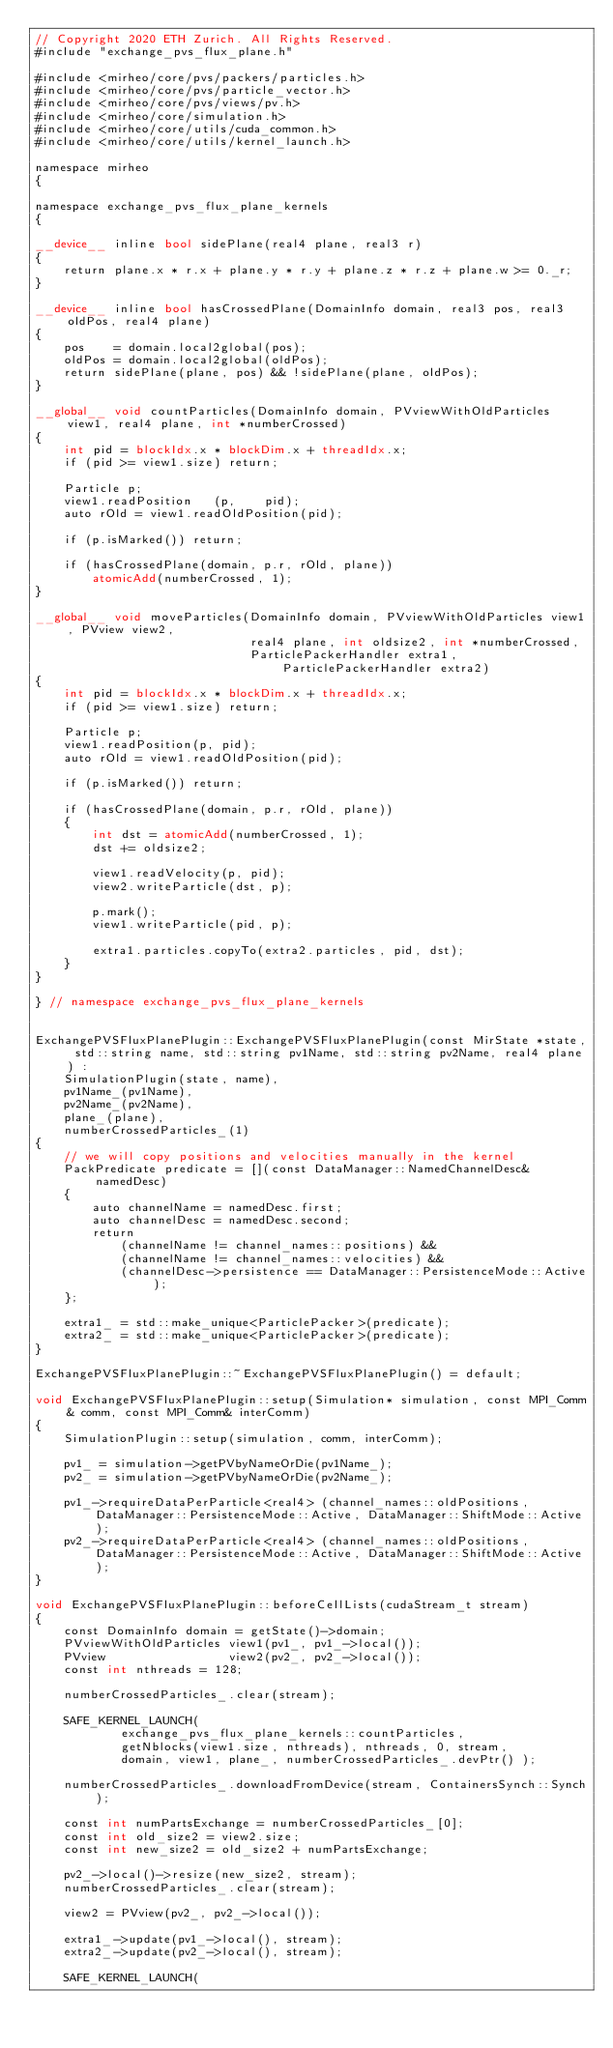Convert code to text. <code><loc_0><loc_0><loc_500><loc_500><_Cuda_>// Copyright 2020 ETH Zurich. All Rights Reserved.
#include "exchange_pvs_flux_plane.h"

#include <mirheo/core/pvs/packers/particles.h>
#include <mirheo/core/pvs/particle_vector.h>
#include <mirheo/core/pvs/views/pv.h>
#include <mirheo/core/simulation.h>
#include <mirheo/core/utils/cuda_common.h>
#include <mirheo/core/utils/kernel_launch.h>

namespace mirheo
{

namespace exchange_pvs_flux_plane_kernels
{

__device__ inline bool sidePlane(real4 plane, real3 r)
{
    return plane.x * r.x + plane.y * r.y + plane.z * r.z + plane.w >= 0._r;
}

__device__ inline bool hasCrossedPlane(DomainInfo domain, real3 pos, real3 oldPos, real4 plane)
{
    pos    = domain.local2global(pos);
    oldPos = domain.local2global(oldPos);
    return sidePlane(plane, pos) && !sidePlane(plane, oldPos);
}

__global__ void countParticles(DomainInfo domain, PVviewWithOldParticles view1, real4 plane, int *numberCrossed)
{
    int pid = blockIdx.x * blockDim.x + threadIdx.x;
    if (pid >= view1.size) return;

    Particle p;
    view1.readPosition   (p,    pid);
    auto rOld = view1.readOldPosition(pid);

    if (p.isMarked()) return;

    if (hasCrossedPlane(domain, p.r, rOld, plane))
        atomicAdd(numberCrossed, 1);
}

__global__ void moveParticles(DomainInfo domain, PVviewWithOldParticles view1, PVview view2,
                              real4 plane, int oldsize2, int *numberCrossed,
                              ParticlePackerHandler extra1, ParticlePackerHandler extra2)
{
    int pid = blockIdx.x * blockDim.x + threadIdx.x;
    if (pid >= view1.size) return;

    Particle p;
    view1.readPosition(p, pid);
    auto rOld = view1.readOldPosition(pid);

    if (p.isMarked()) return;

    if (hasCrossedPlane(domain, p.r, rOld, plane))
    {
        int dst = atomicAdd(numberCrossed, 1);
        dst += oldsize2;

        view1.readVelocity(p, pid);
        view2.writeParticle(dst, p);

        p.mark();
        view1.writeParticle(pid, p);

        extra1.particles.copyTo(extra2.particles, pid, dst);
    }
}

} // namespace exchange_pvs_flux_plane_kernels


ExchangePVSFluxPlanePlugin::ExchangePVSFluxPlanePlugin(const MirState *state, std::string name, std::string pv1Name, std::string pv2Name, real4 plane) :
    SimulationPlugin(state, name),
    pv1Name_(pv1Name),
    pv2Name_(pv2Name),
    plane_(plane),
    numberCrossedParticles_(1)
{
    // we will copy positions and velocities manually in the kernel
    PackPredicate predicate = [](const DataManager::NamedChannelDesc& namedDesc)
    {
        auto channelName = namedDesc.first;
        auto channelDesc = namedDesc.second;
        return
            (channelName != channel_names::positions) &&
            (channelName != channel_names::velocities) &&
            (channelDesc->persistence == DataManager::PersistenceMode::Active);
    };

    extra1_ = std::make_unique<ParticlePacker>(predicate);
    extra2_ = std::make_unique<ParticlePacker>(predicate);
}

ExchangePVSFluxPlanePlugin::~ExchangePVSFluxPlanePlugin() = default;

void ExchangePVSFluxPlanePlugin::setup(Simulation* simulation, const MPI_Comm& comm, const MPI_Comm& interComm)
{
    SimulationPlugin::setup(simulation, comm, interComm);

    pv1_ = simulation->getPVbyNameOrDie(pv1Name_);
    pv2_ = simulation->getPVbyNameOrDie(pv2Name_);

    pv1_->requireDataPerParticle<real4> (channel_names::oldPositions, DataManager::PersistenceMode::Active, DataManager::ShiftMode::Active);
    pv2_->requireDataPerParticle<real4> (channel_names::oldPositions, DataManager::PersistenceMode::Active, DataManager::ShiftMode::Active);
}

void ExchangePVSFluxPlanePlugin::beforeCellLists(cudaStream_t stream)
{
    const DomainInfo domain = getState()->domain;
    PVviewWithOldParticles view1(pv1_, pv1_->local());
    PVview                 view2(pv2_, pv2_->local());
    const int nthreads = 128;

    numberCrossedParticles_.clear(stream);

    SAFE_KERNEL_LAUNCH(
            exchange_pvs_flux_plane_kernels::countParticles,
            getNblocks(view1.size, nthreads), nthreads, 0, stream,
            domain, view1, plane_, numberCrossedParticles_.devPtr() );

    numberCrossedParticles_.downloadFromDevice(stream, ContainersSynch::Synch);

    const int numPartsExchange = numberCrossedParticles_[0];
    const int old_size2 = view2.size;
    const int new_size2 = old_size2 + numPartsExchange;

    pv2_->local()->resize(new_size2, stream);
    numberCrossedParticles_.clear(stream);

    view2 = PVview(pv2_, pv2_->local());

    extra1_->update(pv1_->local(), stream);
    extra2_->update(pv2_->local(), stream);

    SAFE_KERNEL_LAUNCH(</code> 